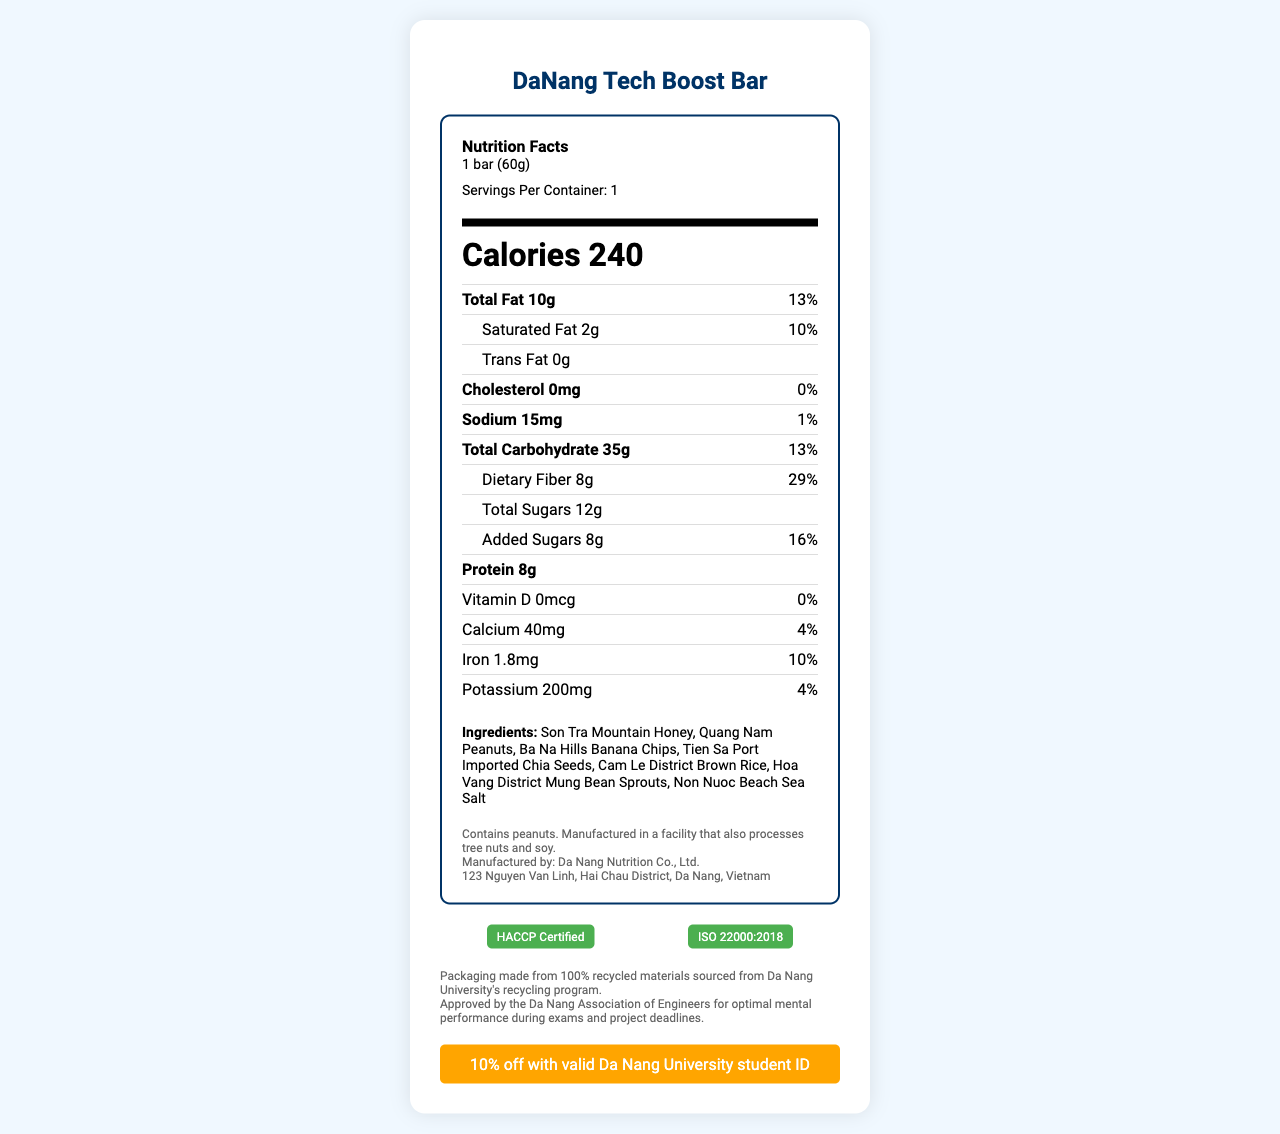what is the serving size of the DaNang Tech Boost Bar? The serving size is clearly stated under the "Nutrition Facts" header as "1 bar (60g)".
Answer: 1 bar (60g) how many calories are in one serving of the DaNang Tech Boost Bar? The calorie content is displayed in bold under the "Nutrition Facts" header.
Answer: 240 calories list three ingredients found in the DaNang Tech Boost Bar. A list of ingredients is provided under the "Ingredients" section of the label.
Answer: Son Tra Mountain Honey, Quang Nam Peanuts, Ba Na Hills Banana Chips how much dietary fiber does the DaNang Tech Boost Bar contain per serving? The amount of dietary fiber per serving is specified in the "Total Carbohydrate" section as "Dietary Fiber 8g".
Answer: 8g who manufactures the DaNang Tech Boost Bar? The manufacturer's information is given in the additional info section as "Manufactured by: Da Nang Nutrition Co., Ltd."
Answer: Da Nang Nutrition Co., Ltd. which certification does the DaNang Tech Boost Bar have? A. USDA Organic B. ISO 22000:2018 C. Non-GMO Project Verified D. Halal Certified The certifications listed include "ISO 22000:2018" and "HACCP Certified".
Answer: B. ISO 22000:2018 what is the percentage daily value of total fat in the DaNang Tech Boost Bar? A. 10% B. 13% C. 29% D. 16% The percentage daily value for total fat is mentioned next to the total fat content as "13%".
Answer: B. 13% is the DaNang Tech Boost Bar suitable for individuals allergic to peanuts? The allergen information specifically notes that the product contains peanuts.
Answer: No describe the main idea of the document. This document is designed to inform consumers about the nutritional profile, ingredients, and other pertinent details such as certifications and sustainability efforts associated with the DaNang Tech Boost Bar.
Answer: The document is a nutritional facts label for the "DaNang Tech Boost Bar" which provides detailed information about its nutritional content, ingredients, allergen information, manufacturer details, certifications, and sustainability initiatives. how much added sugar is in the DaNang Tech Boost Bar? The amount of added sugars per serving is listed under "Total Sugars" as "Added Sugars 8g".
Answer: 8g does the document mention the price of the DaNang Tech Boost Bar? The document does not provide information about the price of the DaNang Tech Boost Bar.
Answer: Not enough information what is the exact address of the manufacturer? The manufacturer's address is listed under the additional info section as "123 Nguyen Van Linh, Hai Chau District, Da Nang, Vietnam".
Answer: 123 Nguyen Van Linh, Hai Chau District, Da Nang, Vietnam what is the percent daily value of iron per serving? The percentage daily value for iron is listed next to the iron content as "10%".
Answer: 10% what initiative does the packaging of the DaNang Tech Boost Bar support? The document mentions that the packaging is made from "100% recycled materials sourced from Da Nang University's recycling program".
Answer: Da Nang University's recycling program how much protein does the DaNang Tech Boost Bar contain? The protein content per serving is specified under the "Nutrition Facts" as "Protein 8g".
Answer: 8g 